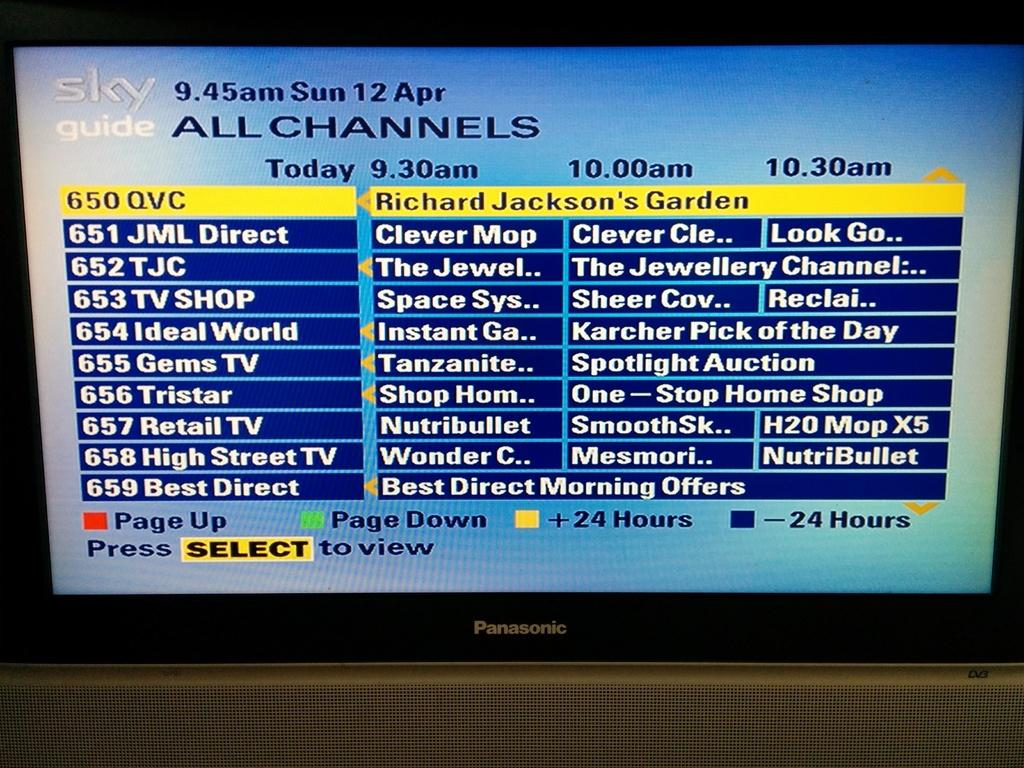<image>
Write a terse but informative summary of the picture. Sky guide television channel menu screen showing all channels available. 